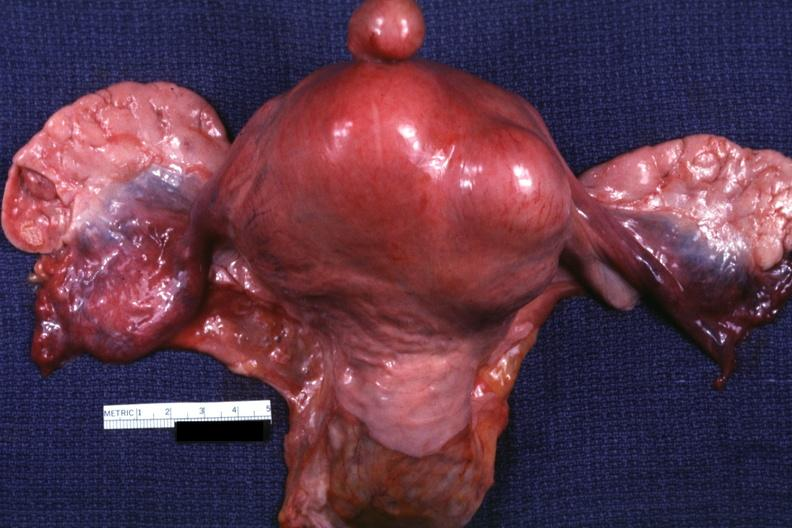does this image show unopened uterus tubes and ovaries?
Answer the question using a single word or phrase. Yes 